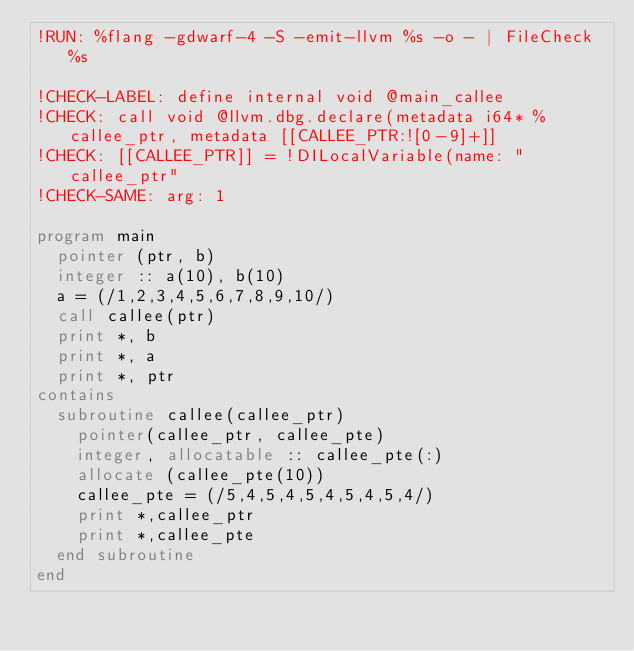Convert code to text. <code><loc_0><loc_0><loc_500><loc_500><_FORTRAN_>!RUN: %flang -gdwarf-4 -S -emit-llvm %s -o - | FileCheck %s

!CHECK-LABEL: define internal void @main_callee
!CHECK: call void @llvm.dbg.declare(metadata i64* %callee_ptr, metadata [[CALLEE_PTR:![0-9]+]]
!CHECK: [[CALLEE_PTR]] = !DILocalVariable(name: "callee_ptr"
!CHECK-SAME: arg: 1

program main
  pointer (ptr, b)
  integer :: a(10), b(10)
  a = (/1,2,3,4,5,6,7,8,9,10/)
  call callee(ptr)
  print *, b 
  print *, a
  print *, ptr
contains
  subroutine callee(callee_ptr)
    pointer(callee_ptr, callee_pte)
    integer, allocatable :: callee_pte(:)
    allocate (callee_pte(10))
    callee_pte = (/5,4,5,4,5,4,5,4,5,4/)
    print *,callee_ptr
    print *,callee_pte
  end subroutine
end
</code> 